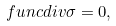Convert formula to latex. <formula><loc_0><loc_0><loc_500><loc_500>\ f u n c { d i v } \sigma = 0 ,</formula> 